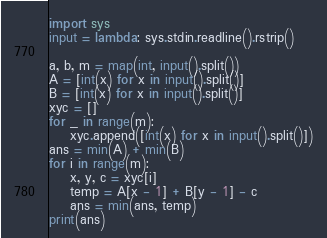Convert code to text. <code><loc_0><loc_0><loc_500><loc_500><_Python_>import sys
input = lambda: sys.stdin.readline().rstrip()

a, b, m = map(int, input().split())
A = [int(x) for x in input().split()]
B = [int(x) for x in input().split()]
xyc = []
for _ in range(m):
    xyc.append([int(x) for x in input().split()])
ans = min(A) + min(B)
for i in range(m):
    x, y, c = xyc[i]
    temp = A[x - 1] + B[y - 1] - c
    ans = min(ans, temp)
print(ans)</code> 